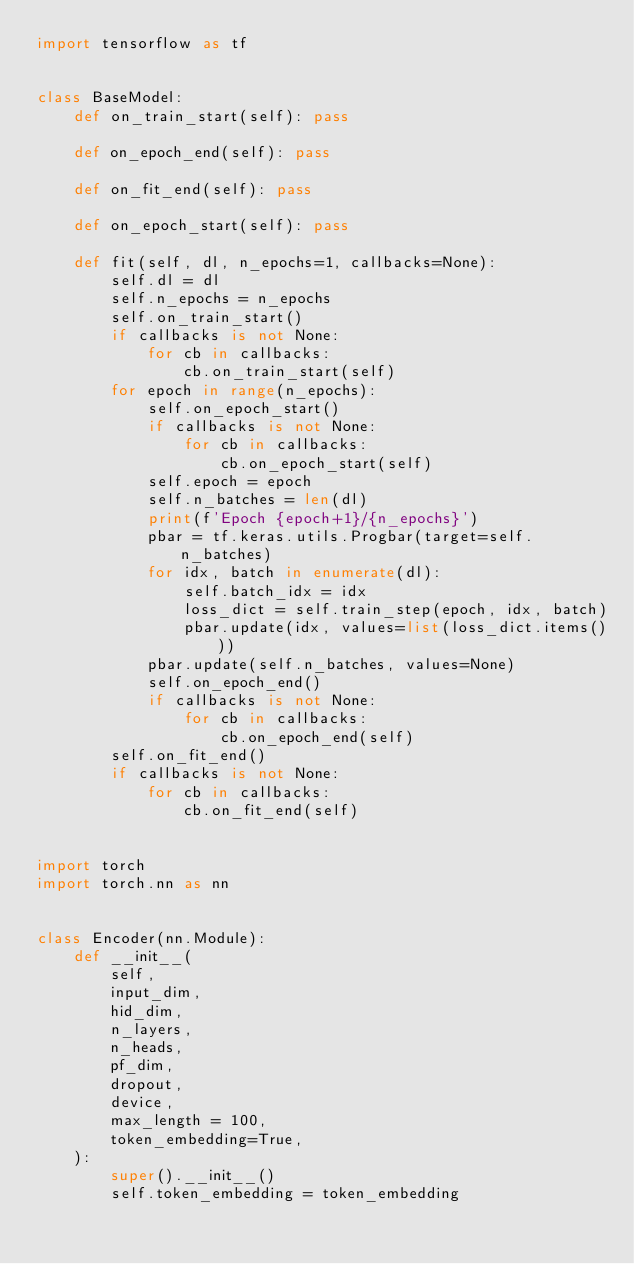<code> <loc_0><loc_0><loc_500><loc_500><_Python_>import tensorflow as tf


class BaseModel:
    def on_train_start(self): pass
    
    def on_epoch_end(self): pass
    
    def on_fit_end(self): pass
    
    def on_epoch_start(self): pass
                        
    def fit(self, dl, n_epochs=1, callbacks=None):
        self.dl = dl
        self.n_epochs = n_epochs
        self.on_train_start()
        if callbacks is not None:
            for cb in callbacks:
                cb.on_train_start(self)
        for epoch in range(n_epochs):
            self.on_epoch_start()
            if callbacks is not None:
                for cb in callbacks:
                    cb.on_epoch_start(self)
            self.epoch = epoch
            self.n_batches = len(dl)
            print(f'Epoch {epoch+1}/{n_epochs}')
            pbar = tf.keras.utils.Progbar(target=self.n_batches)
            for idx, batch in enumerate(dl):
                self.batch_idx = idx
                loss_dict = self.train_step(epoch, idx, batch) 
                pbar.update(idx, values=list(loss_dict.items()))
            pbar.update(self.n_batches, values=None)
            self.on_epoch_end()
            if callbacks is not None:
                for cb in callbacks:
                    cb.on_epoch_end(self)
        self.on_fit_end()
        if callbacks is not None:
            for cb in callbacks:
                cb.on_fit_end(self)
    
    
import torch
import torch.nn as nn


class Encoder(nn.Module):
    def __init__(
        self, 
        input_dim, 
        hid_dim, 
        n_layers, 
        n_heads, 
        pf_dim,
        dropout, 
        device,
        max_length = 100,
        token_embedding=True,
    ):
        super().__init__()
        self.token_embedding = token_embedding</code> 